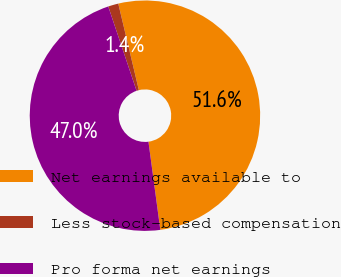<chart> <loc_0><loc_0><loc_500><loc_500><pie_chart><fcel>Net earnings available to<fcel>Less stock-based compensation<fcel>Pro forma net earnings<nl><fcel>51.59%<fcel>1.44%<fcel>46.97%<nl></chart> 